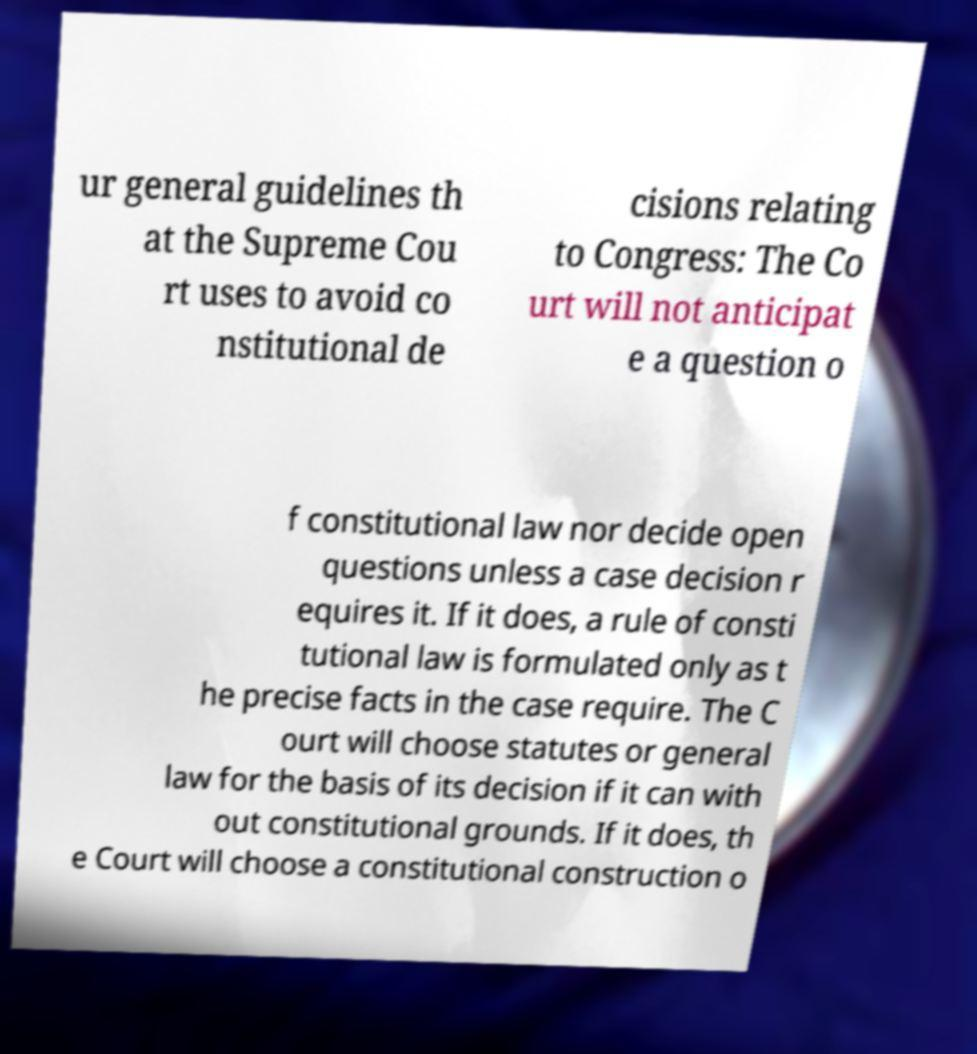Can you accurately transcribe the text from the provided image for me? ur general guidelines th at the Supreme Cou rt uses to avoid co nstitutional de cisions relating to Congress: The Co urt will not anticipat e a question o f constitutional law nor decide open questions unless a case decision r equires it. If it does, a rule of consti tutional law is formulated only as t he precise facts in the case require. The C ourt will choose statutes or general law for the basis of its decision if it can with out constitutional grounds. If it does, th e Court will choose a constitutional construction o 